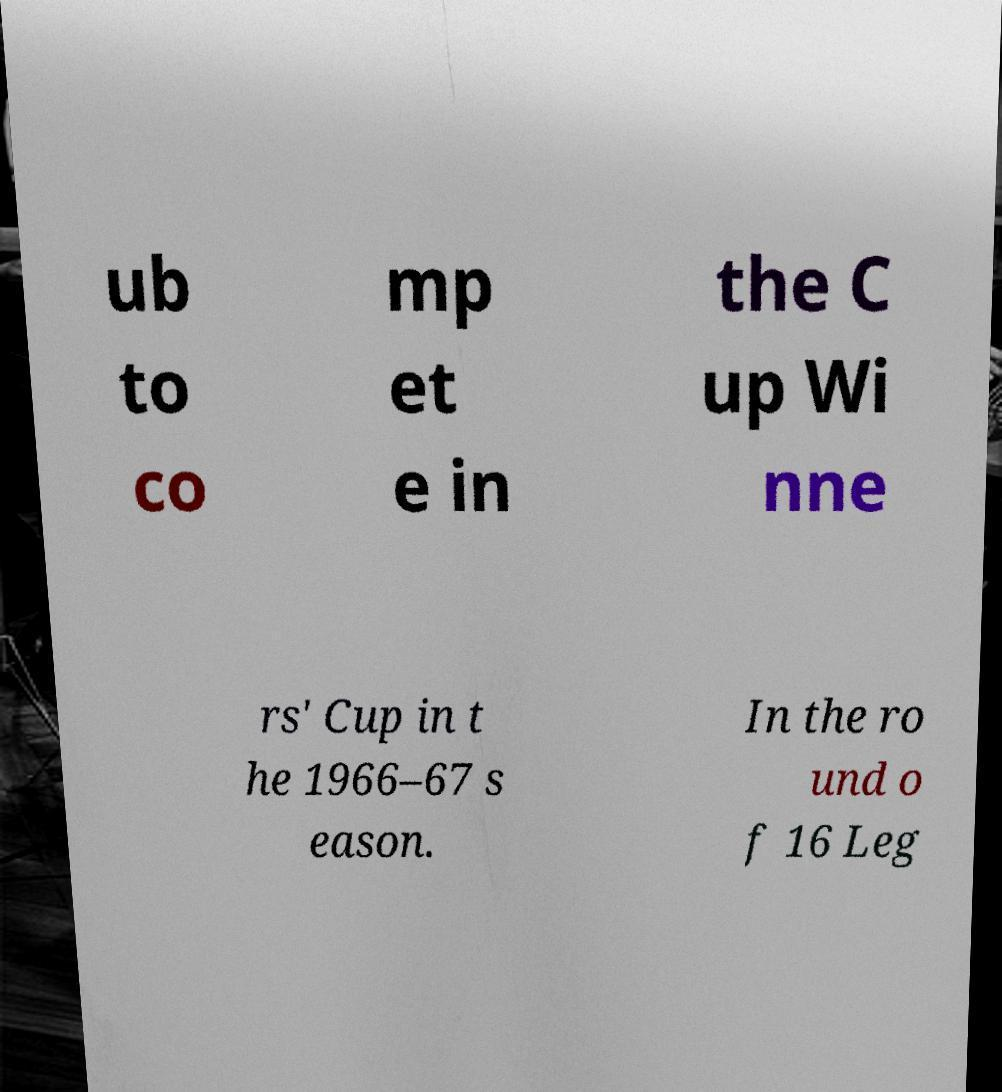Can you accurately transcribe the text from the provided image for me? ub to co mp et e in the C up Wi nne rs' Cup in t he 1966–67 s eason. In the ro und o f 16 Leg 